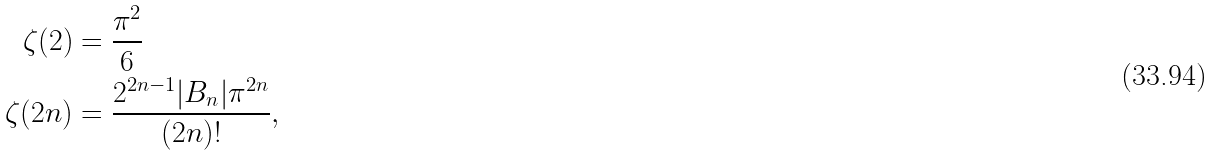<formula> <loc_0><loc_0><loc_500><loc_500>\zeta ( 2 ) & = \frac { \pi ^ { 2 } } { 6 } \\ \zeta ( 2 n ) & = \frac { 2 ^ { 2 n - 1 } | B _ { n } | \pi ^ { 2 n } } { ( 2 n ) ! } ,</formula> 